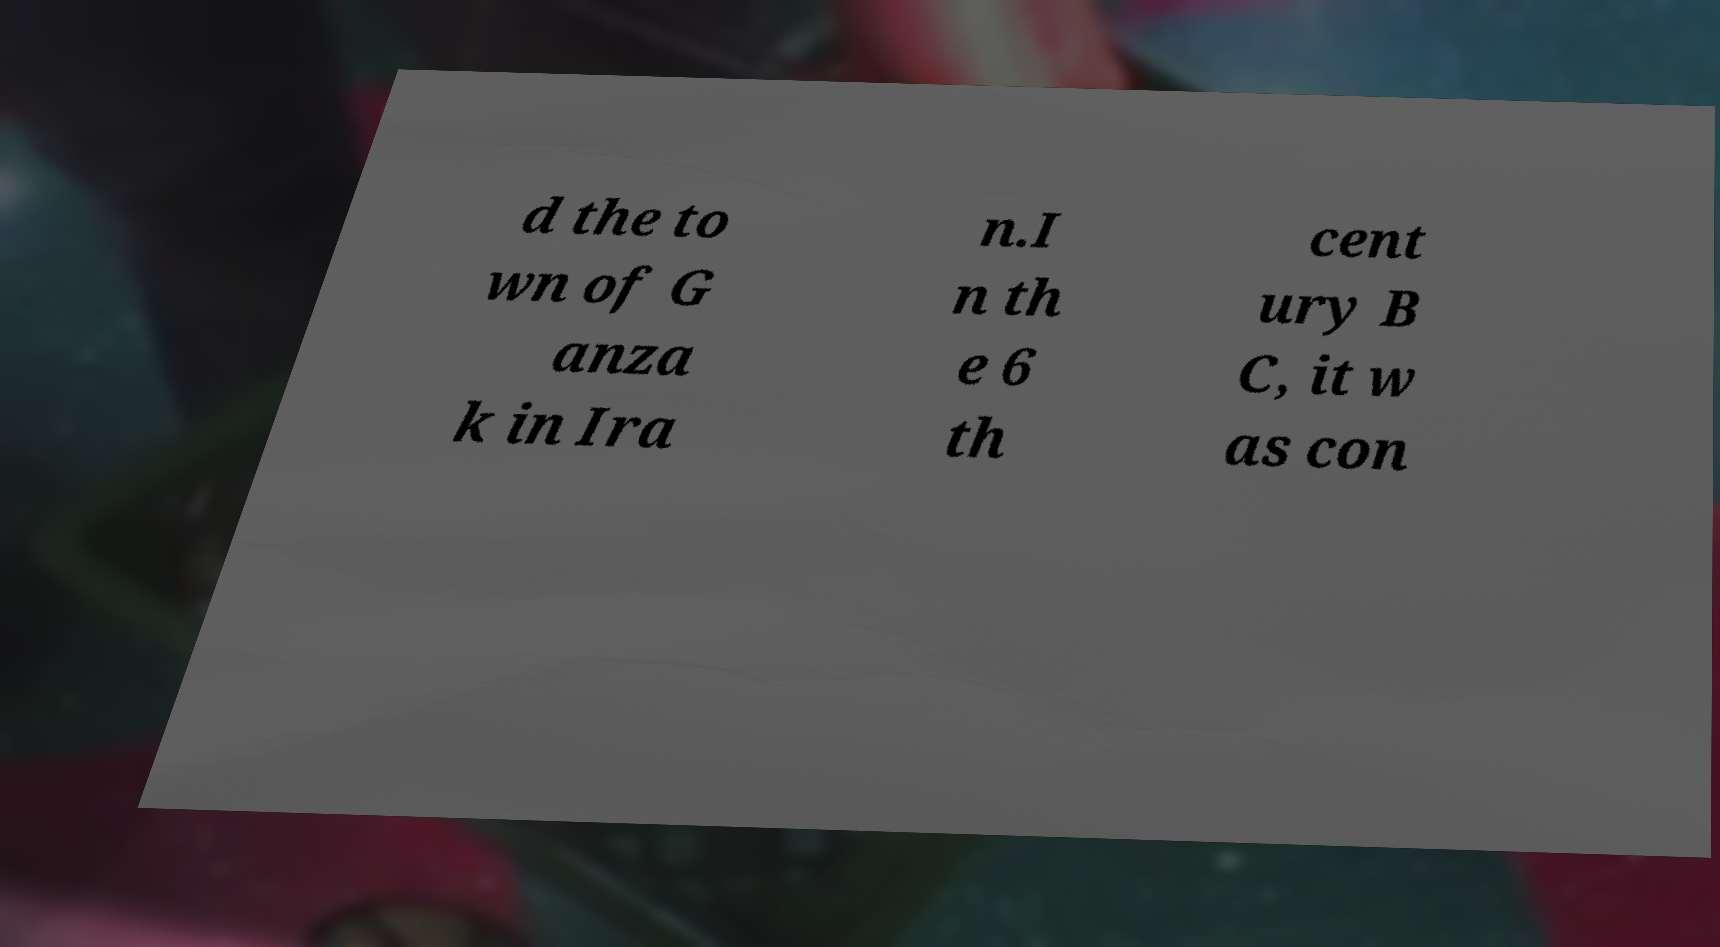Can you read and provide the text displayed in the image?This photo seems to have some interesting text. Can you extract and type it out for me? d the to wn of G anza k in Ira n.I n th e 6 th cent ury B C, it w as con 